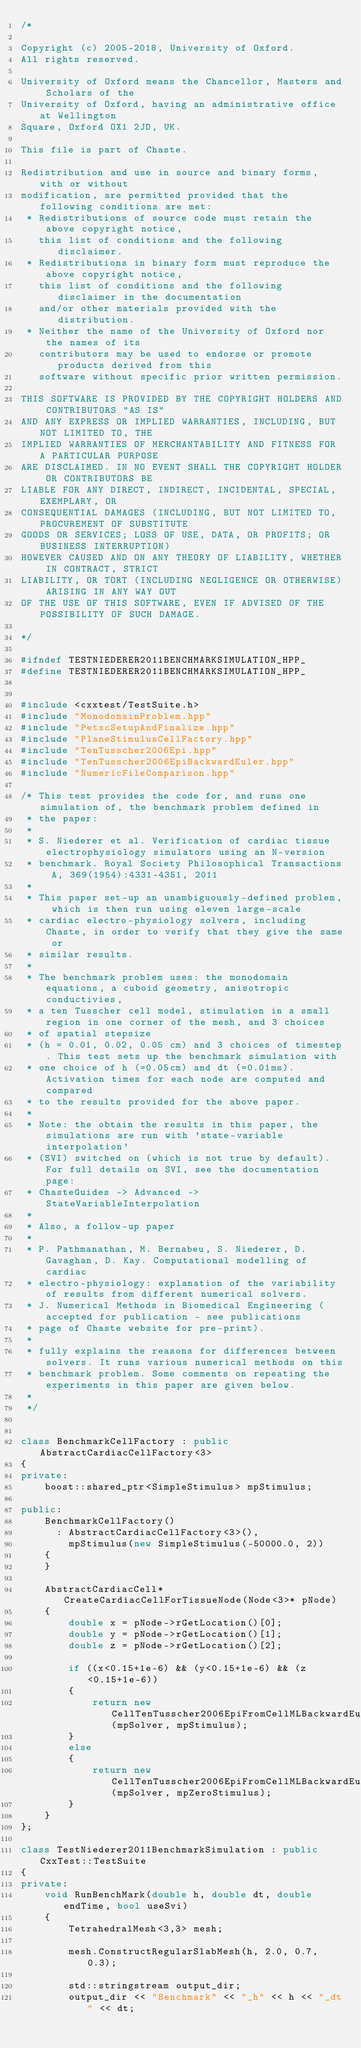<code> <loc_0><loc_0><loc_500><loc_500><_C++_>/*

Copyright (c) 2005-2018, University of Oxford.
All rights reserved.

University of Oxford means the Chancellor, Masters and Scholars of the
University of Oxford, having an administrative office at Wellington
Square, Oxford OX1 2JD, UK.

This file is part of Chaste.

Redistribution and use in source and binary forms, with or without
modification, are permitted provided that the following conditions are met:
 * Redistributions of source code must retain the above copyright notice,
   this list of conditions and the following disclaimer.
 * Redistributions in binary form must reproduce the above copyright notice,
   this list of conditions and the following disclaimer in the documentation
   and/or other materials provided with the distribution.
 * Neither the name of the University of Oxford nor the names of its
   contributors may be used to endorse or promote products derived from this
   software without specific prior written permission.

THIS SOFTWARE IS PROVIDED BY THE COPYRIGHT HOLDERS AND CONTRIBUTORS "AS IS"
AND ANY EXPRESS OR IMPLIED WARRANTIES, INCLUDING, BUT NOT LIMITED TO, THE
IMPLIED WARRANTIES OF MERCHANTABILITY AND FITNESS FOR A PARTICULAR PURPOSE
ARE DISCLAIMED. IN NO EVENT SHALL THE COPYRIGHT HOLDER OR CONTRIBUTORS BE
LIABLE FOR ANY DIRECT, INDIRECT, INCIDENTAL, SPECIAL, EXEMPLARY, OR
CONSEQUENTIAL DAMAGES (INCLUDING, BUT NOT LIMITED TO, PROCUREMENT OF SUBSTITUTE
GOODS OR SERVICES; LOSS OF USE, DATA, OR PROFITS; OR BUSINESS INTERRUPTION)
HOWEVER CAUSED AND ON ANY THEORY OF LIABILITY, WHETHER IN CONTRACT, STRICT
LIABILITY, OR TORT (INCLUDING NEGLIGENCE OR OTHERWISE) ARISING IN ANY WAY OUT
OF THE USE OF THIS SOFTWARE, EVEN IF ADVISED OF THE POSSIBILITY OF SUCH DAMAGE.

*/

#ifndef TESTNIEDERER2011BENCHMARKSIMULATION_HPP_
#define TESTNIEDERER2011BENCHMARKSIMULATION_HPP_


#include <cxxtest/TestSuite.h>
#include "MonodomainProblem.hpp"
#include "PetscSetupAndFinalize.hpp"
#include "PlaneStimulusCellFactory.hpp"
#include "TenTusscher2006Epi.hpp"
#include "TenTusscher2006EpiBackwardEuler.hpp"
#include "NumericFileComparison.hpp"

/* This test provides the code for, and runs one simulation of, the benchmark problem defined in
 * the paper:
 *
 * S. Niederer et al. Verification of cardiac tissue electrophysiology simulators using an N-version
 * benchmark. Royal Society Philosophical Transactions A, 369(1954):4331-4351, 2011
 *
 * This paper set-up an unambiguously-defined problem, which is then run using eleven large-scale
 * cardiac electro-physiology solvers, including Chaste, in order to verify that they give the same or
 * similar results.
 *
 * The benchmark problem uses: the monodomain equations, a cuboid geometry, anisotropic conductivies,
 * a ten Tusscher cell model, stimulation in a small region in one corner of the mesh, and 3 choices
 * of spatial stepsize
 * (h = 0.01, 0.02, 0.05 cm) and 3 choices of timestep. This test sets up the benchmark simulation with
 * one choice of h (=0.05cm) and dt (=0.01ms). Activation times for each node are computed and compared
 * to the results provided for the above paper.
 *
 * Note: the obtain the results in this paper, the simulations are run with 'state-variable interpolation'
 * (SVI) switched on (which is not true by default). For full details on SVI, see the documentation page:
 * ChasteGuides -> Advanced -> StateVariableInterpolation
 *
 * Also, a follow-up paper
 *
 * P. Pathmanathan, M. Bernabeu, S. Niederer, D. Gavaghan, D. Kay. Computational modelling of cardiac
 * electro-physiology: explanation of the variability of results from different numerical solvers.
 * J. Numerical Methods in Biomedical Engineering (accepted for publication - see publications
 * page of Chaste website for pre-print).
 *
 * fully explains the reasons for differences between solvers. It runs various numerical methods on this
 * benchmark problem. Some comments on repeating the experiments in this paper are given below.
 *
 */


class BenchmarkCellFactory : public AbstractCardiacCellFactory<3>
{
private:
    boost::shared_ptr<SimpleStimulus> mpStimulus;

public:
    BenchmarkCellFactory()
      : AbstractCardiacCellFactory<3>(),
        mpStimulus(new SimpleStimulus(-50000.0, 2))
    {
    }

    AbstractCardiacCell* CreateCardiacCellForTissueNode(Node<3>* pNode)
    {
        double x = pNode->rGetLocation()[0];
        double y = pNode->rGetLocation()[1];
        double z = pNode->rGetLocation()[2];

        if ((x<0.15+1e-6) && (y<0.15+1e-6) && (z<0.15+1e-6))
        {
            return new CellTenTusscher2006EpiFromCellMLBackwardEuler(mpSolver, mpStimulus);
        }
        else
        {
            return new CellTenTusscher2006EpiFromCellMLBackwardEuler(mpSolver, mpZeroStimulus);
        }
    }
};

class TestNiederer2011BenchmarkSimulation : public CxxTest::TestSuite
{
private:
    void RunBenchMark(double h, double dt, double endTime, bool useSvi)
    {
        TetrahedralMesh<3,3> mesh;

        mesh.ConstructRegularSlabMesh(h, 2.0, 0.7, 0.3);

        std::stringstream output_dir;
        output_dir << "Benchmark" << "_h" << h << "_dt" << dt;
</code> 